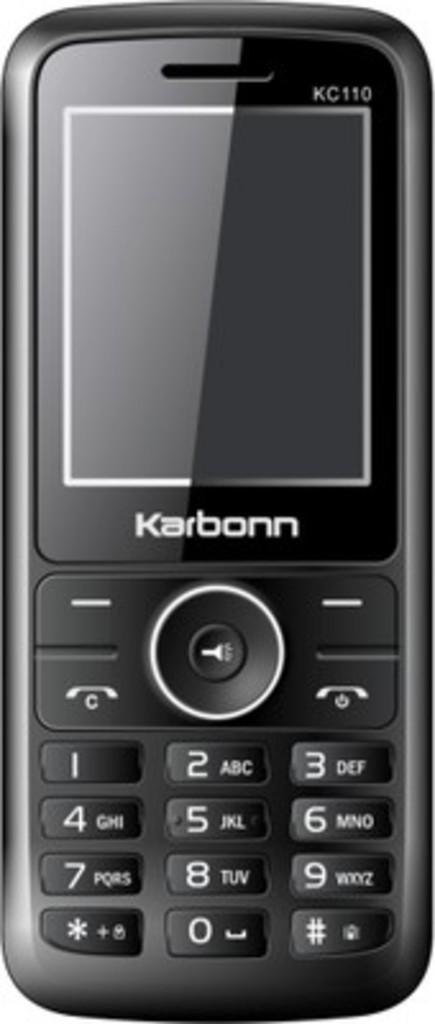Provide a one-sentence caption for the provided image. Black cellphone that is made by the brand Karbonn. 